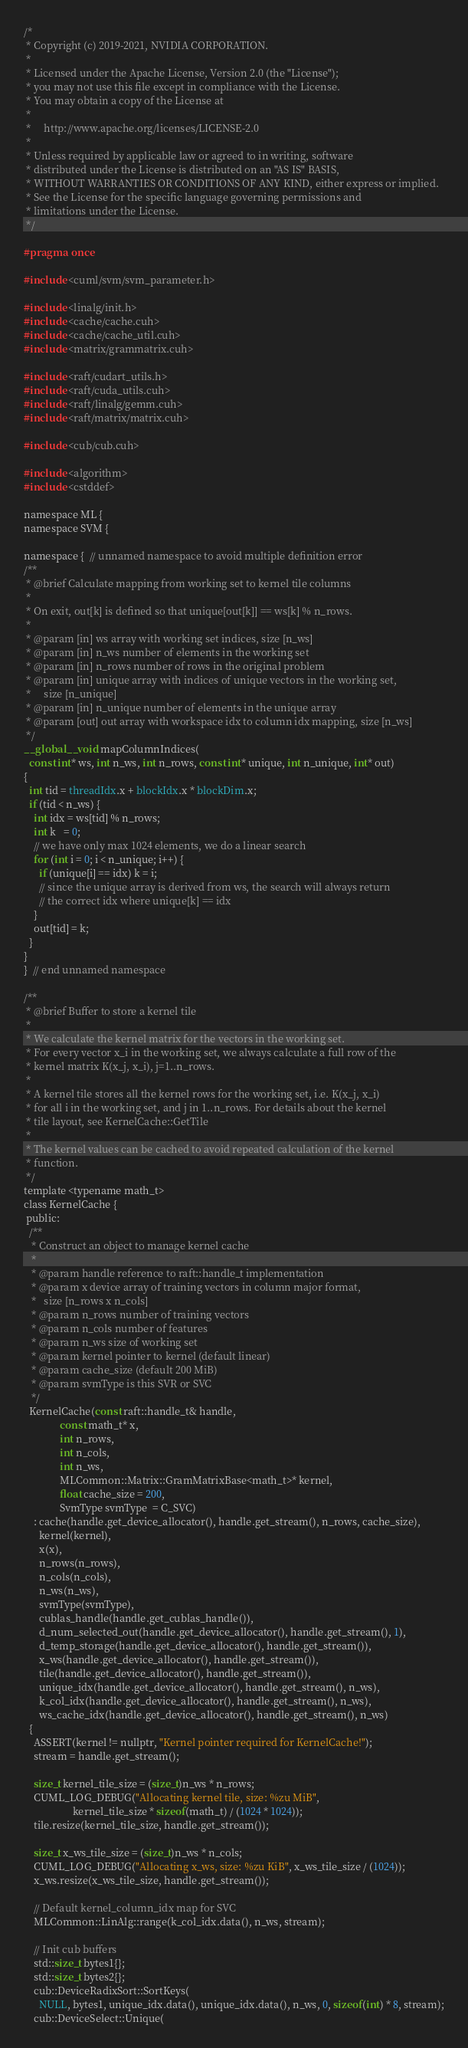<code> <loc_0><loc_0><loc_500><loc_500><_Cuda_>/*
 * Copyright (c) 2019-2021, NVIDIA CORPORATION.
 *
 * Licensed under the Apache License, Version 2.0 (the "License");
 * you may not use this file except in compliance with the License.
 * You may obtain a copy of the License at
 *
 *     http://www.apache.org/licenses/LICENSE-2.0
 *
 * Unless required by applicable law or agreed to in writing, software
 * distributed under the License is distributed on an "AS IS" BASIS,
 * WITHOUT WARRANTIES OR CONDITIONS OF ANY KIND, either express or implied.
 * See the License for the specific language governing permissions and
 * limitations under the License.
 */

#pragma once

#include <cuml/svm/svm_parameter.h>

#include <linalg/init.h>
#include <cache/cache.cuh>
#include <cache/cache_util.cuh>
#include <matrix/grammatrix.cuh>

#include <raft/cudart_utils.h>
#include <raft/cuda_utils.cuh>
#include <raft/linalg/gemm.cuh>
#include <raft/matrix/matrix.cuh>

#include <cub/cub.cuh>

#include <algorithm>
#include <cstddef>

namespace ML {
namespace SVM {

namespace {  // unnamed namespace to avoid multiple definition error
/**
 * @brief Calculate mapping from working set to kernel tile columns
 *
 * On exit, out[k] is defined so that unique[out[k]] == ws[k] % n_rows.
 *
 * @param [in] ws array with working set indices, size [n_ws]
 * @param [in] n_ws number of elements in the working set
 * @param [in] n_rows number of rows in the original problem
 * @param [in] unique array with indices of unique vectors in the working set,
 *     size [n_unique]
 * @param [in] n_unique number of elements in the unique array
 * @param [out] out array with workspace idx to column idx mapping, size [n_ws]
 */
__global__ void mapColumnIndices(
  const int* ws, int n_ws, int n_rows, const int* unique, int n_unique, int* out)
{
  int tid = threadIdx.x + blockIdx.x * blockDim.x;
  if (tid < n_ws) {
    int idx = ws[tid] % n_rows;
    int k   = 0;
    // we have only max 1024 elements, we do a linear search
    for (int i = 0; i < n_unique; i++) {
      if (unique[i] == idx) k = i;
      // since the unique array is derived from ws, the search will always return
      // the correct idx where unique[k] == idx
    }
    out[tid] = k;
  }
}
}  // end unnamed namespace

/**
 * @brief Buffer to store a kernel tile
 *
 * We calculate the kernel matrix for the vectors in the working set.
 * For every vector x_i in the working set, we always calculate a full row of the
 * kernel matrix K(x_j, x_i), j=1..n_rows.
 *
 * A kernel tile stores all the kernel rows for the working set, i.e. K(x_j, x_i)
 * for all i in the working set, and j in 1..n_rows. For details about the kernel
 * tile layout, see KernelCache::GetTile
 *
 * The kernel values can be cached to avoid repeated calculation of the kernel
 * function.
 */
template <typename math_t>
class KernelCache {
 public:
  /**
   * Construct an object to manage kernel cache
   *
   * @param handle reference to raft::handle_t implementation
   * @param x device array of training vectors in column major format,
   *   size [n_rows x n_cols]
   * @param n_rows number of training vectors
   * @param n_cols number of features
   * @param n_ws size of working set
   * @param kernel pointer to kernel (default linear)
   * @param cache_size (default 200 MiB)
   * @param svmType is this SVR or SVC
   */
  KernelCache(const raft::handle_t& handle,
              const math_t* x,
              int n_rows,
              int n_cols,
              int n_ws,
              MLCommon::Matrix::GramMatrixBase<math_t>* kernel,
              float cache_size = 200,
              SvmType svmType  = C_SVC)
    : cache(handle.get_device_allocator(), handle.get_stream(), n_rows, cache_size),
      kernel(kernel),
      x(x),
      n_rows(n_rows),
      n_cols(n_cols),
      n_ws(n_ws),
      svmType(svmType),
      cublas_handle(handle.get_cublas_handle()),
      d_num_selected_out(handle.get_device_allocator(), handle.get_stream(), 1),
      d_temp_storage(handle.get_device_allocator(), handle.get_stream()),
      x_ws(handle.get_device_allocator(), handle.get_stream()),
      tile(handle.get_device_allocator(), handle.get_stream()),
      unique_idx(handle.get_device_allocator(), handle.get_stream(), n_ws),
      k_col_idx(handle.get_device_allocator(), handle.get_stream(), n_ws),
      ws_cache_idx(handle.get_device_allocator(), handle.get_stream(), n_ws)
  {
    ASSERT(kernel != nullptr, "Kernel pointer required for KernelCache!");
    stream = handle.get_stream();

    size_t kernel_tile_size = (size_t)n_ws * n_rows;
    CUML_LOG_DEBUG("Allocating kernel tile, size: %zu MiB",
                   kernel_tile_size * sizeof(math_t) / (1024 * 1024));
    tile.resize(kernel_tile_size, handle.get_stream());

    size_t x_ws_tile_size = (size_t)n_ws * n_cols;
    CUML_LOG_DEBUG("Allocating x_ws, size: %zu KiB", x_ws_tile_size / (1024));
    x_ws.resize(x_ws_tile_size, handle.get_stream());

    // Default kernel_column_idx map for SVC
    MLCommon::LinAlg::range(k_col_idx.data(), n_ws, stream);

    // Init cub buffers
    std::size_t bytes1{};
    std::size_t bytes2{};
    cub::DeviceRadixSort::SortKeys(
      NULL, bytes1, unique_idx.data(), unique_idx.data(), n_ws, 0, sizeof(int) * 8, stream);
    cub::DeviceSelect::Unique(</code> 